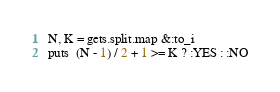Convert code to text. <code><loc_0><loc_0><loc_500><loc_500><_Ruby_>N, K = gets.split.map &:to_i
puts  (N - 1) / 2 + 1 >= K ? :YES : :NO</code> 